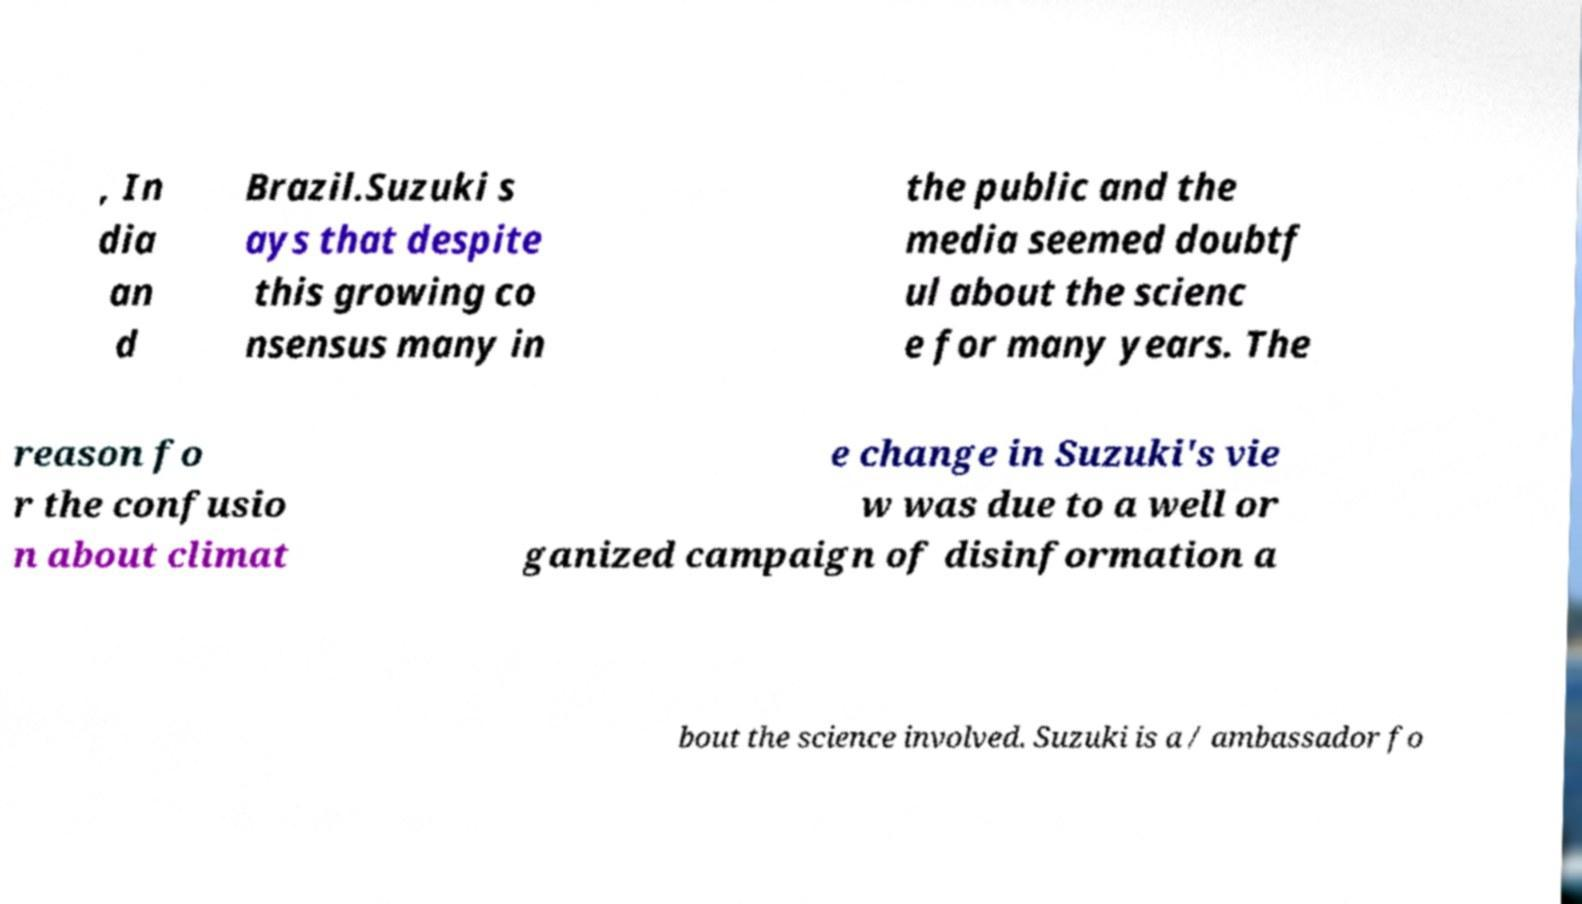Could you assist in decoding the text presented in this image and type it out clearly? , In dia an d Brazil.Suzuki s ays that despite this growing co nsensus many in the public and the media seemed doubtf ul about the scienc e for many years. The reason fo r the confusio n about climat e change in Suzuki's vie w was due to a well or ganized campaign of disinformation a bout the science involved. Suzuki is a / ambassador fo 